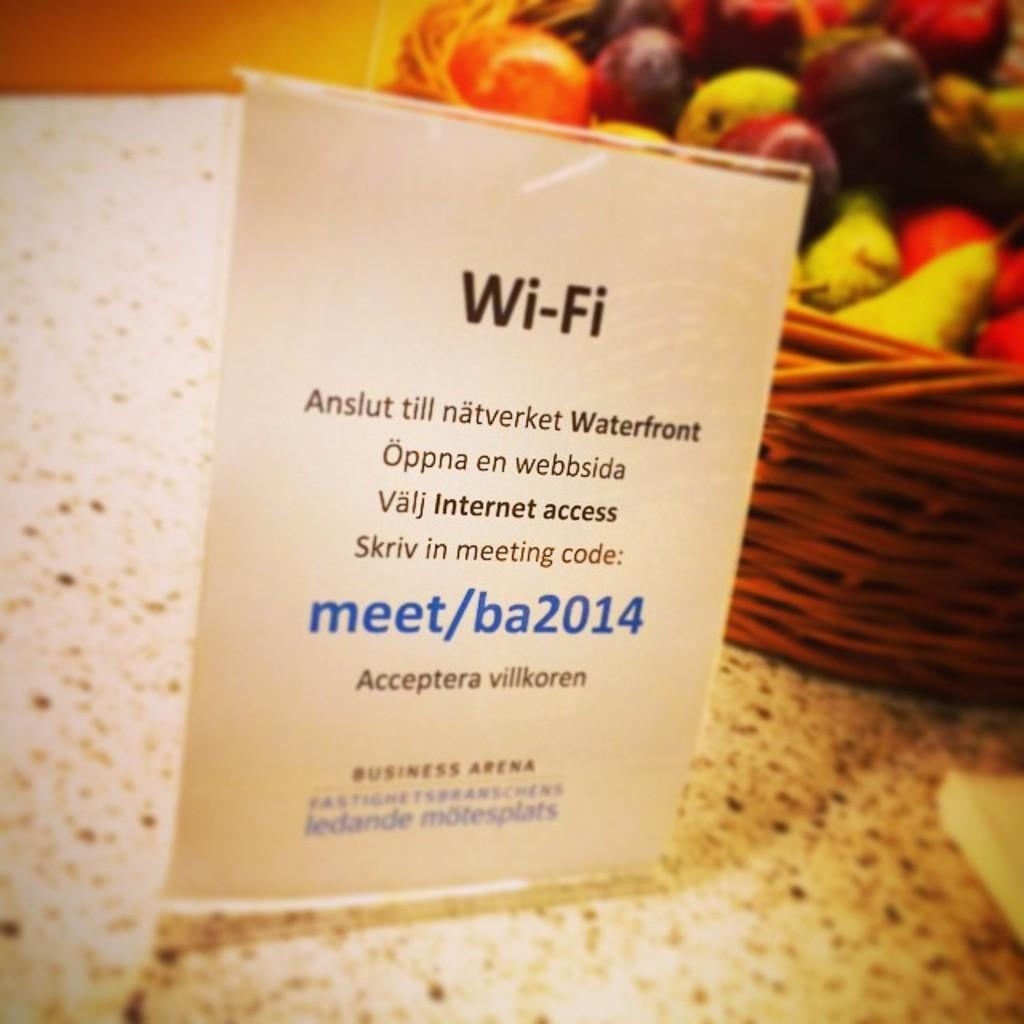What is attached to the tag in the image? The tag has text and numbers in the image. Where is the basket located in the image? The basket is on the right side of the image. What is inside the basket? The basket contains fruits. What type of cheese is being served for breakfast in the image? There is no cheese or breakfast depicted in the image; it features a tag and a basket of fruits. 